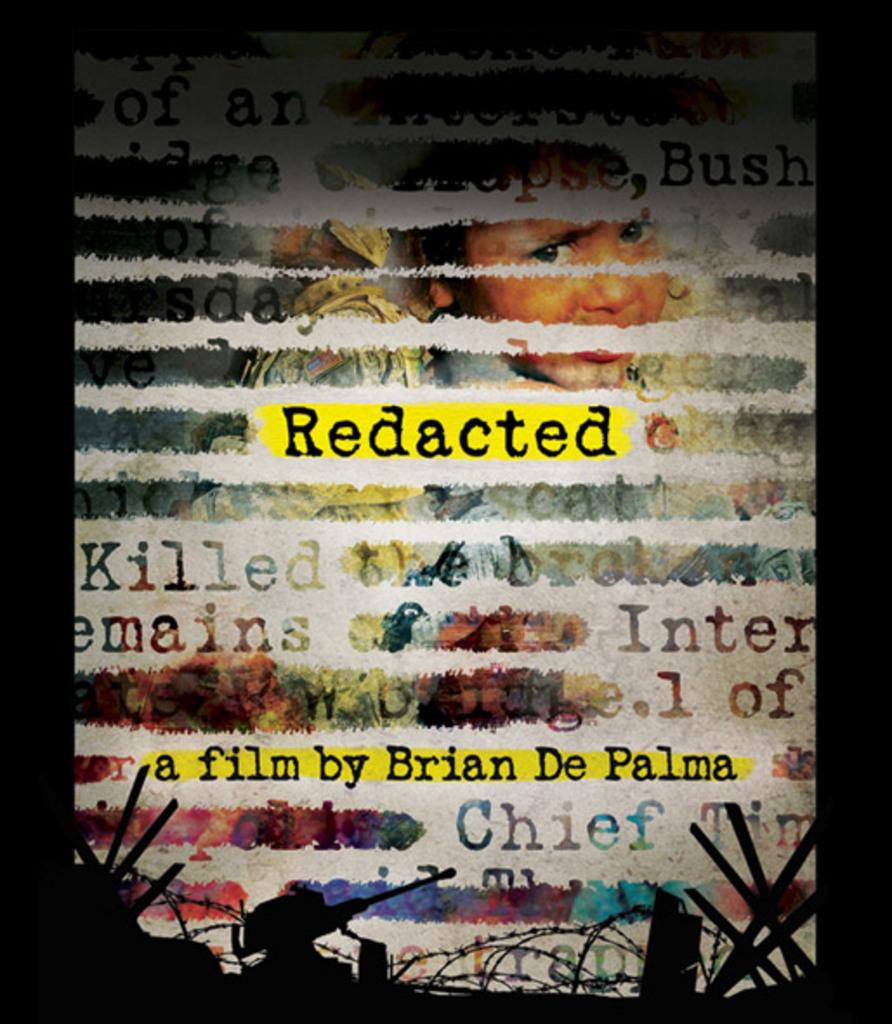What can be found in the image that conveys information or ideas? There is text in the image that conveys information or ideas. What type of visual elements are present in the image besides text? There are images of people in the image. What structural elements can be seen in the image? There are rods visible in the image and a wire fence in the image. What is located at the bottom of the image? There are objects visible at the bottom of the image. How does the duck in the image demonstrate respect for the wire fence? There is no duck present in the image, so it cannot demonstrate respect for the wire fence. 